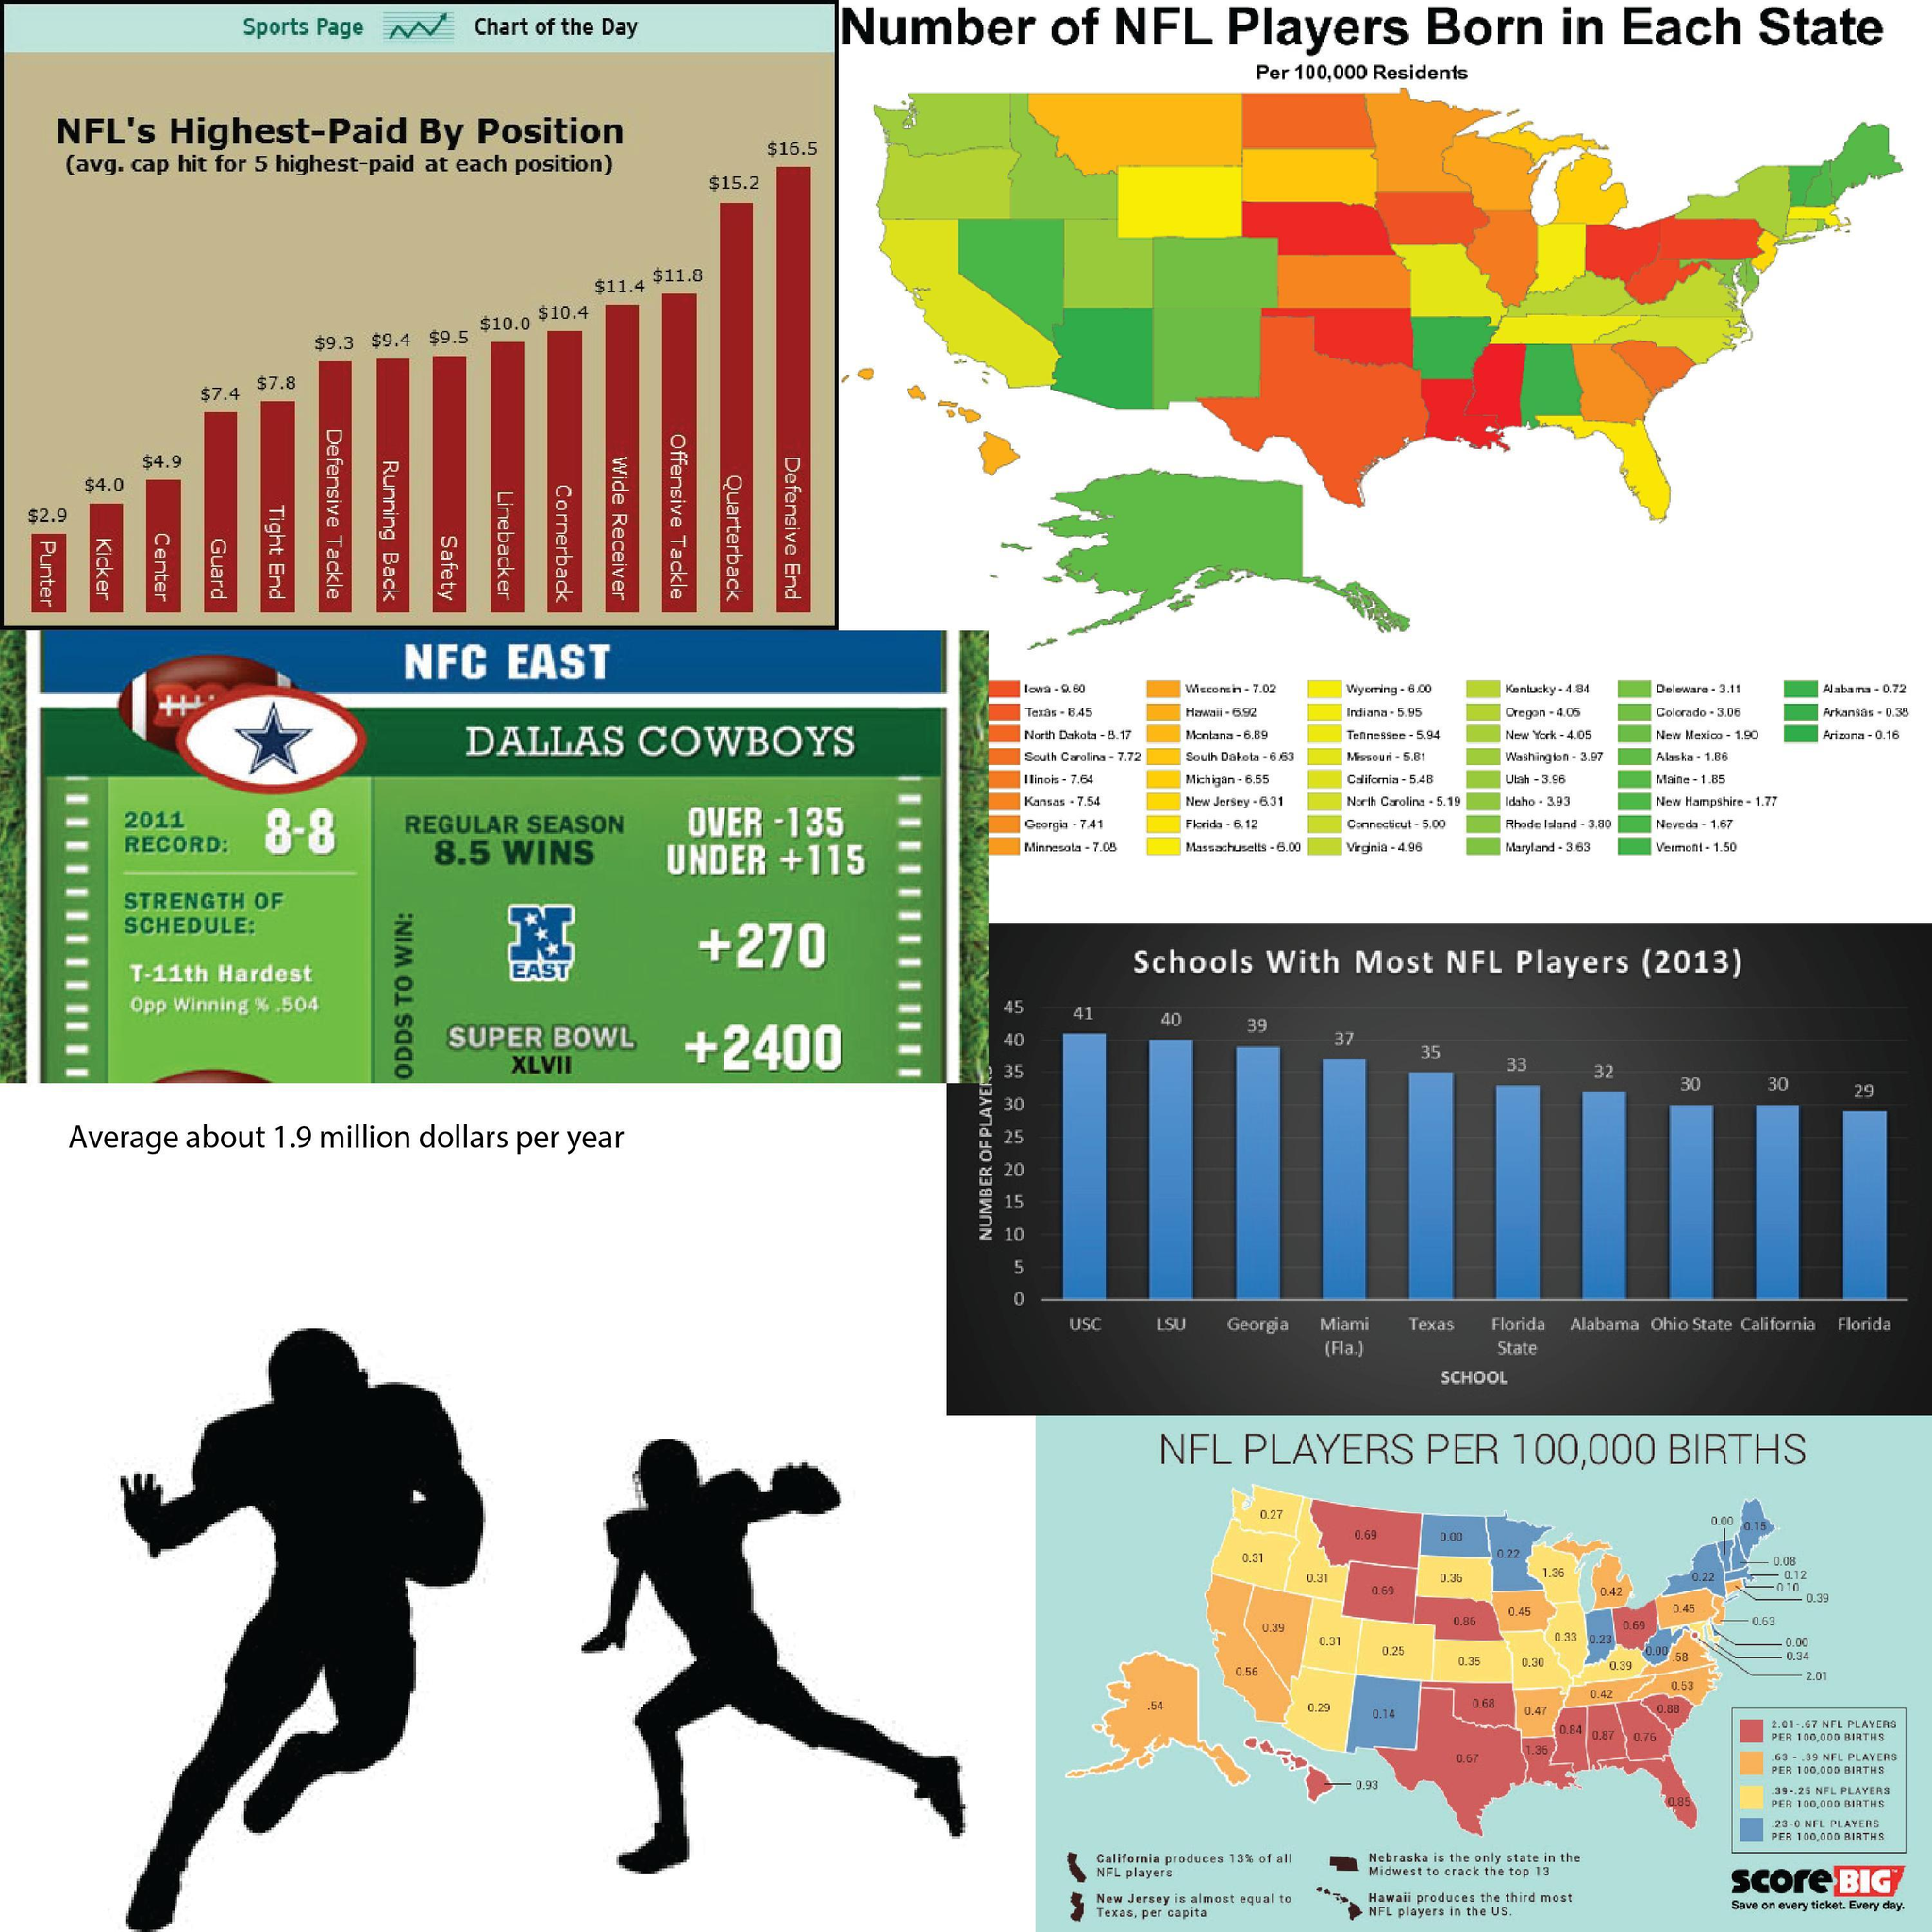Which is the second-highest paid position in NFL?
Answer the question with a short phrase. Quarterback What is the average capital hit for the position of Quarterback in NFL games? $15.2 What is the number of NFL players per 100,000 births in Florida? 0.85 What is the number of NFL players per 100,000 births in Texas? 0.67 Which U.S. state has the least number of NFL players born per 100,000 residents? Arizona What is the number of NFL players born in Hawaii per 100,000 residents? 6.92 What is the average capital hit for the position of Wide Receiver in NFL games? $11.4 Which school produces the second-most number of NFL players in 2013? LSU Which NFL position gets paid the most? Defensive End Which U.S. state has the highest number of NFL players born per 100,000 residents? Iowa 